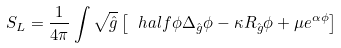Convert formula to latex. <formula><loc_0><loc_0><loc_500><loc_500>S _ { L } = \frac { 1 } { 4 \pi } \int \sqrt { \hat { g } } \left [ \ h a l f \phi \Delta _ { \hat { g } } \phi - \kappa R _ { \hat { g } } \phi + { \mu } e ^ { \alpha \phi } \right ]</formula> 